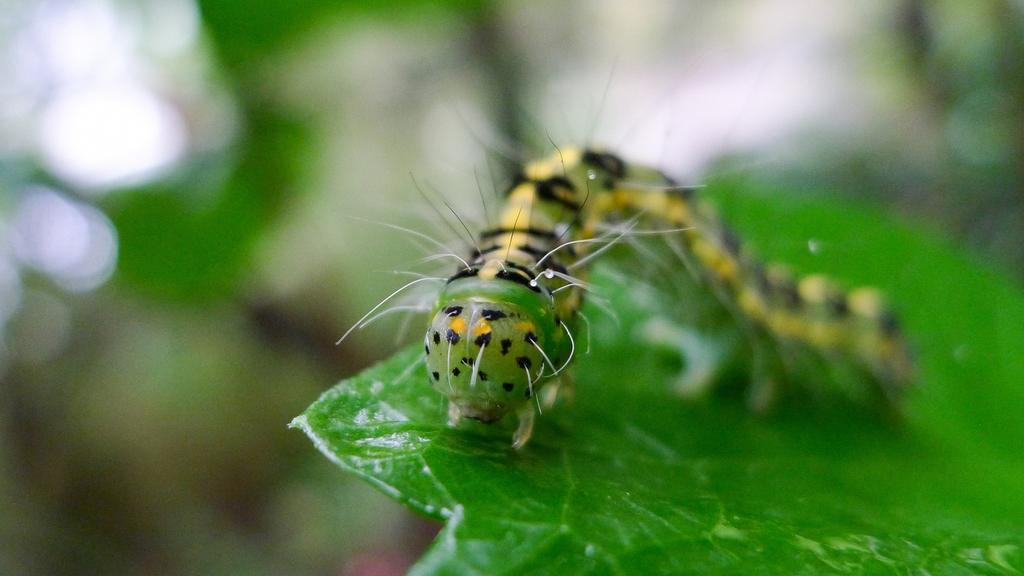What is the main subject of the image? There is a caterpillar in the image. What is the caterpillar doing in the image? The caterpillar is crawling on a leaf. What type of crime is being committed by the caterpillar in the image? There is no crime being committed by the caterpillar in the image; it is simply crawling on a leaf. 